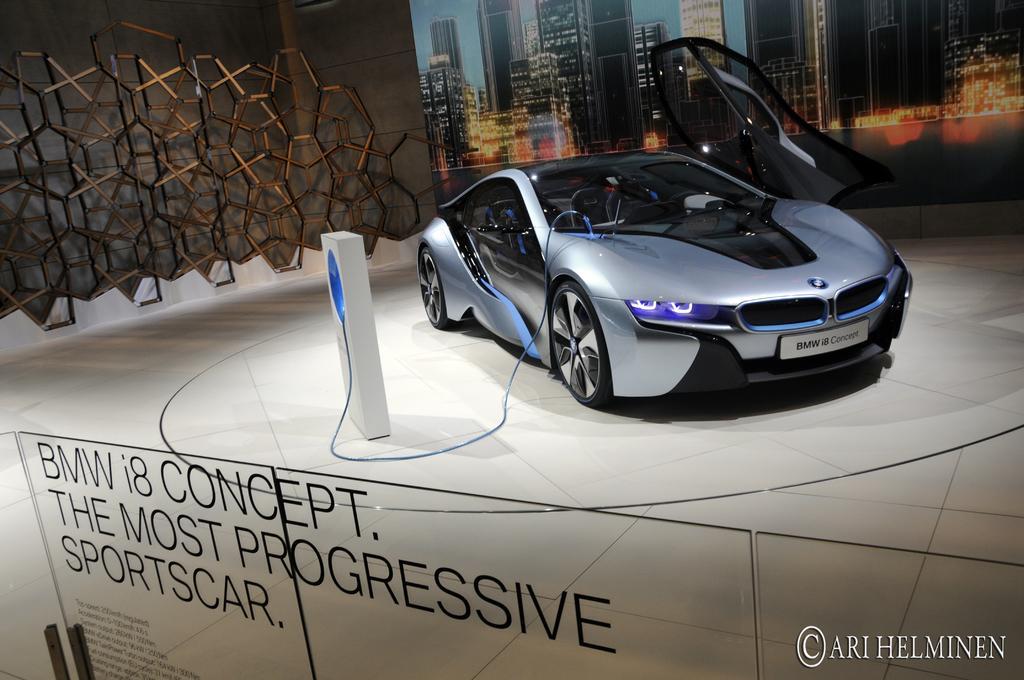How would you summarize this image in a sentence or two? This image consists of a car. At the bottom, there is a glass board. In the background, there is a wall. And a poster on the wall. 